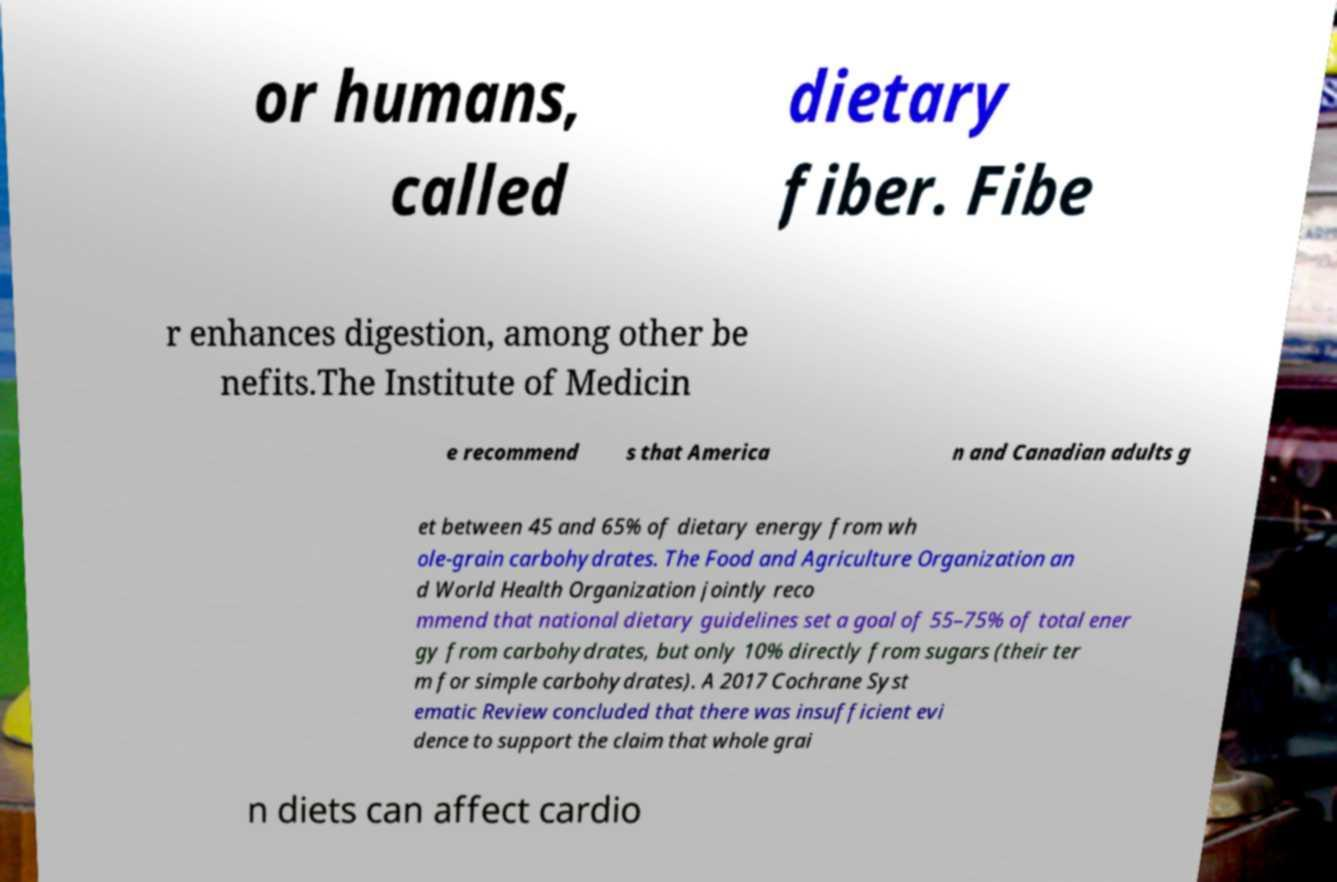Can you read and provide the text displayed in the image?This photo seems to have some interesting text. Can you extract and type it out for me? or humans, called dietary fiber. Fibe r enhances digestion, among other be nefits.The Institute of Medicin e recommend s that America n and Canadian adults g et between 45 and 65% of dietary energy from wh ole-grain carbohydrates. The Food and Agriculture Organization an d World Health Organization jointly reco mmend that national dietary guidelines set a goal of 55–75% of total ener gy from carbohydrates, but only 10% directly from sugars (their ter m for simple carbohydrates). A 2017 Cochrane Syst ematic Review concluded that there was insufficient evi dence to support the claim that whole grai n diets can affect cardio 